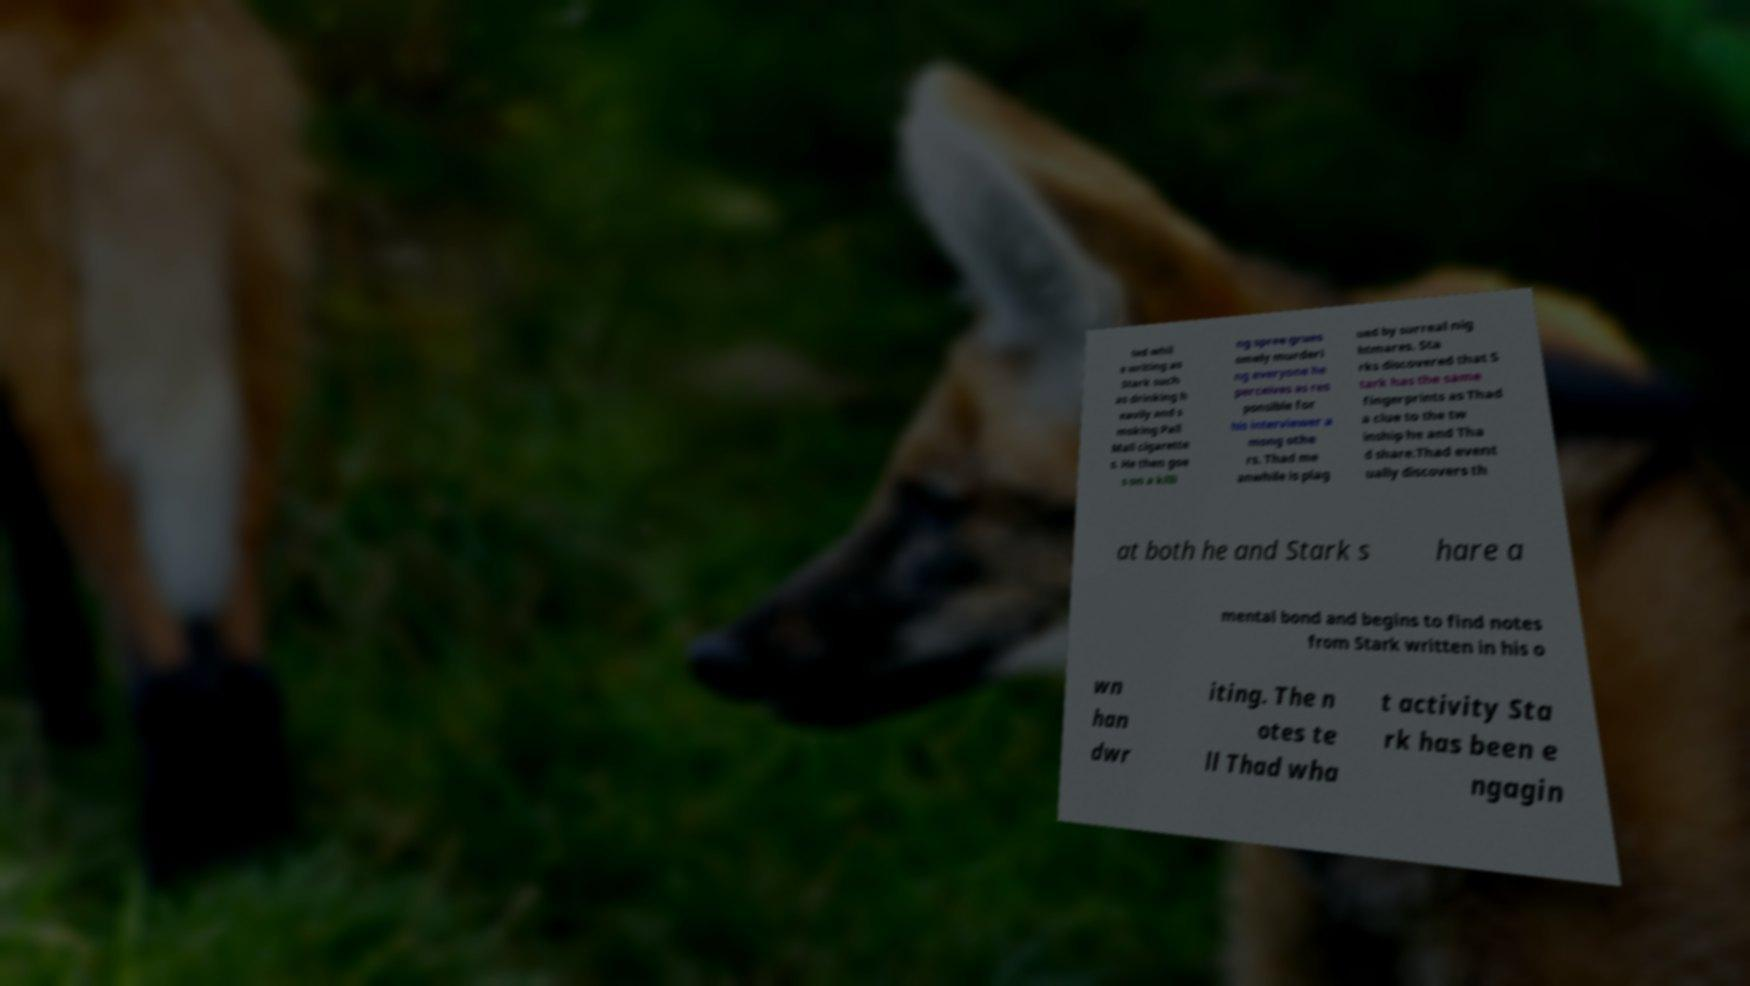What messages or text are displayed in this image? I need them in a readable, typed format. ted whil e writing as Stark such as drinking h eavily and s moking Pall Mall cigarette s. He then goe s on a killi ng spree grues omely murderi ng everyone he perceives as res ponsible for his interviewer a mong othe rs. Thad me anwhile is plag ued by surreal nig htmares. Sta rks discovered that S tark has the same fingerprints as Thad a clue to the tw inship he and Tha d share.Thad event ually discovers th at both he and Stark s hare a mental bond and begins to find notes from Stark written in his o wn han dwr iting. The n otes te ll Thad wha t activity Sta rk has been e ngagin 